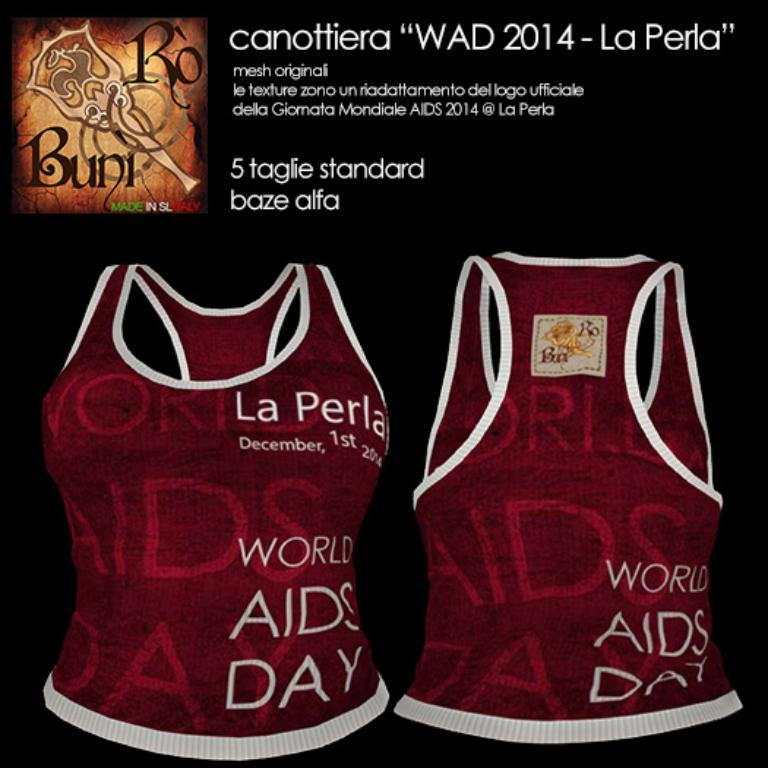Provide a one-sentence caption for the provided image. A foreign advertisement for World AIDS Day tank tops. 